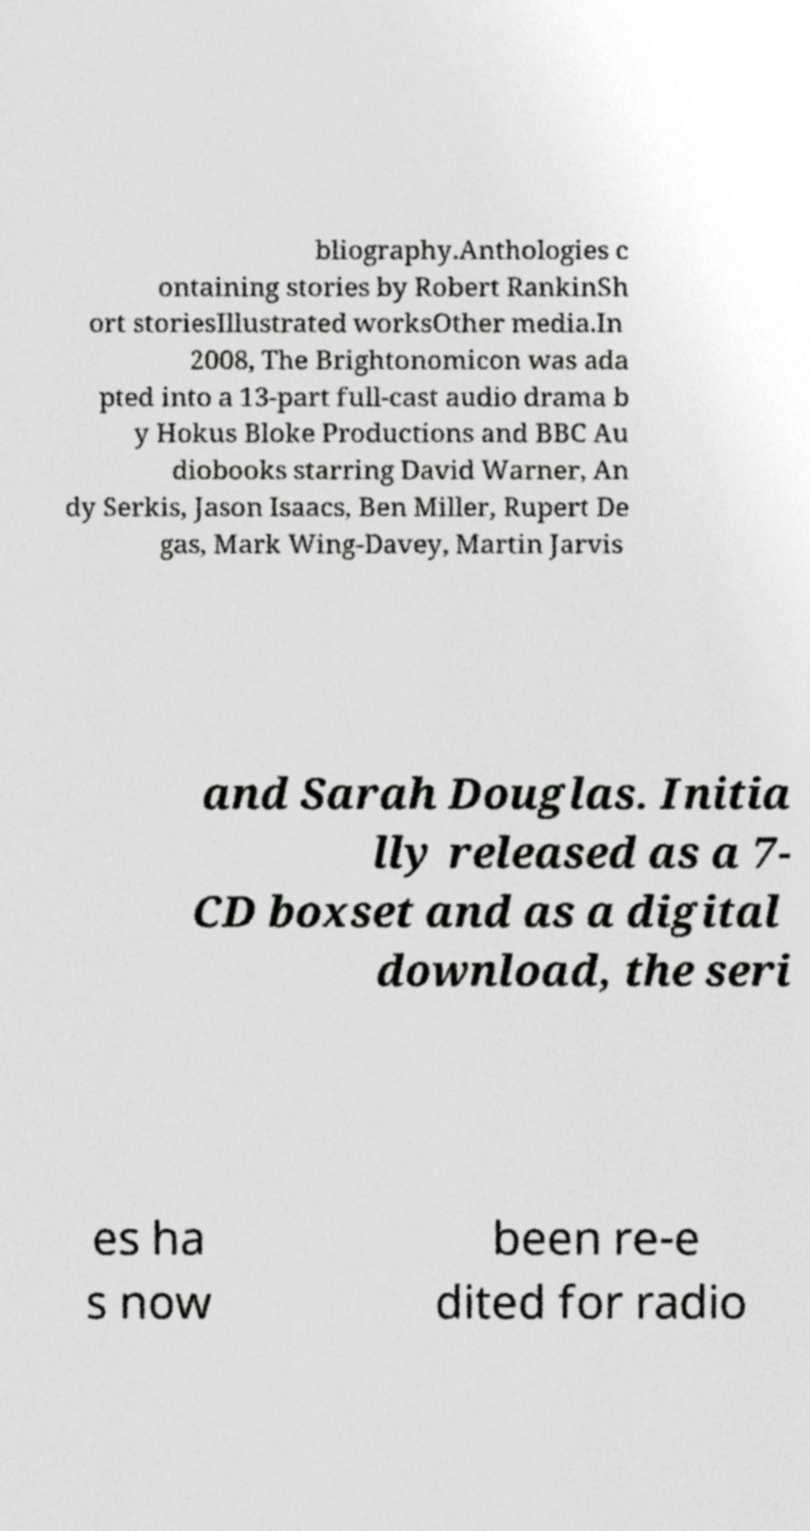Could you assist in decoding the text presented in this image and type it out clearly? bliography.Anthologies c ontaining stories by Robert RankinSh ort storiesIllustrated worksOther media.In 2008, The Brightonomicon was ada pted into a 13-part full-cast audio drama b y Hokus Bloke Productions and BBC Au diobooks starring David Warner, An dy Serkis, Jason Isaacs, Ben Miller, Rupert De gas, Mark Wing-Davey, Martin Jarvis and Sarah Douglas. Initia lly released as a 7- CD boxset and as a digital download, the seri es ha s now been re-e dited for radio 